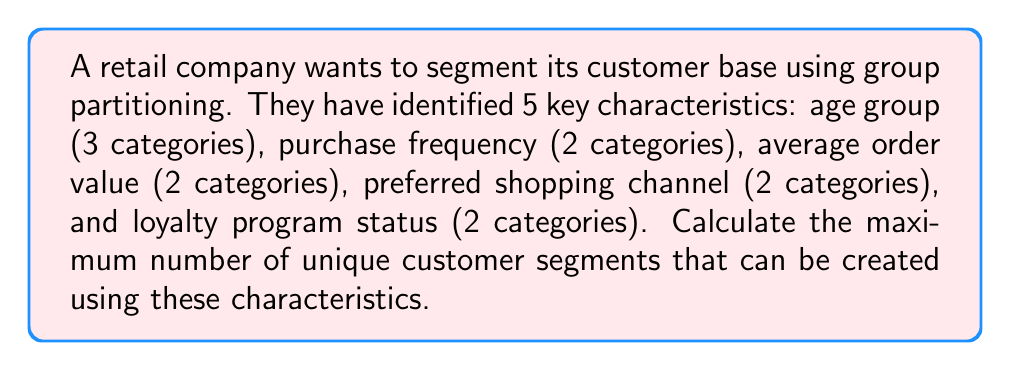Can you answer this question? To solve this problem, we need to use the concept of group partitioning from group theory. In this case, we are partitioning the set of all customers based on different characteristics.

1. First, let's identify the number of categories for each characteristic:
   - Age group: 3 categories
   - Purchase frequency: 2 categories
   - Average order value: 2 categories
   - Preferred shopping channel: 2 categories
   - Loyalty program status: 2 categories

2. To find the total number of unique segments, we need to calculate the product of the number of categories for each characteristic. This is because each unique combination of categories across all characteristics represents a distinct customer segment.

3. The calculation can be represented as:

   $$ \text{Total segments} = 3 \times 2 \times 2 \times 2 \times 2 $$

4. Simplifying the calculation:

   $$ \text{Total segments} = 3 \times 2^4 = 3 \times 16 = 48 $$

Therefore, the maximum number of unique customer segments that can be created using these characteristics is 48.

This partitioning allows the retail company to create highly specific customer segments, which can be used to tailor marketing strategies and integrate online and offline approaches more effectively.
Answer: 48 unique customer segments 